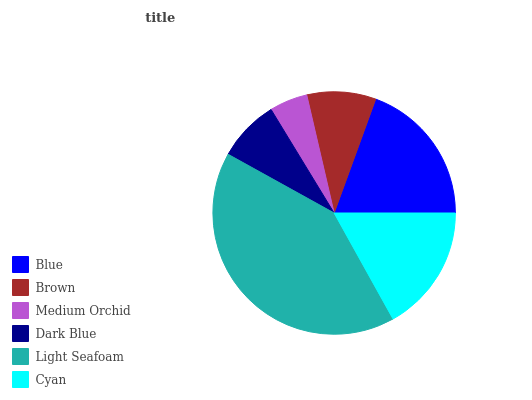Is Medium Orchid the minimum?
Answer yes or no. Yes. Is Light Seafoam the maximum?
Answer yes or no. Yes. Is Brown the minimum?
Answer yes or no. No. Is Brown the maximum?
Answer yes or no. No. Is Blue greater than Brown?
Answer yes or no. Yes. Is Brown less than Blue?
Answer yes or no. Yes. Is Brown greater than Blue?
Answer yes or no. No. Is Blue less than Brown?
Answer yes or no. No. Is Cyan the high median?
Answer yes or no. Yes. Is Brown the low median?
Answer yes or no. Yes. Is Dark Blue the high median?
Answer yes or no. No. Is Cyan the low median?
Answer yes or no. No. 